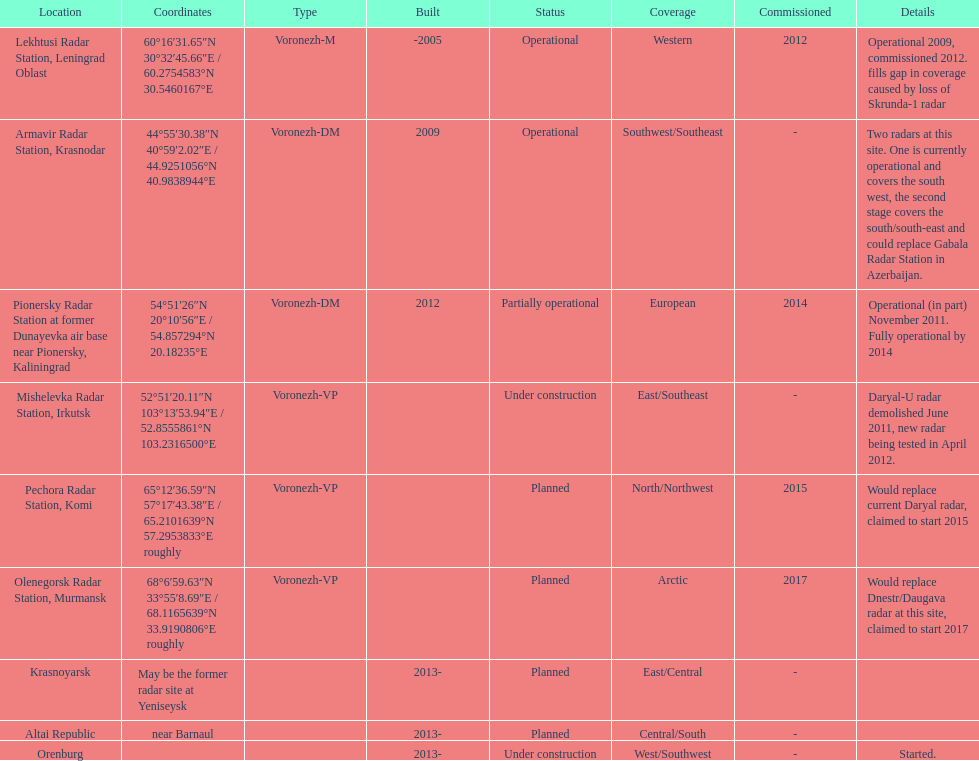How many voronezh radars are in kaliningrad or in krasnodar? 2. 